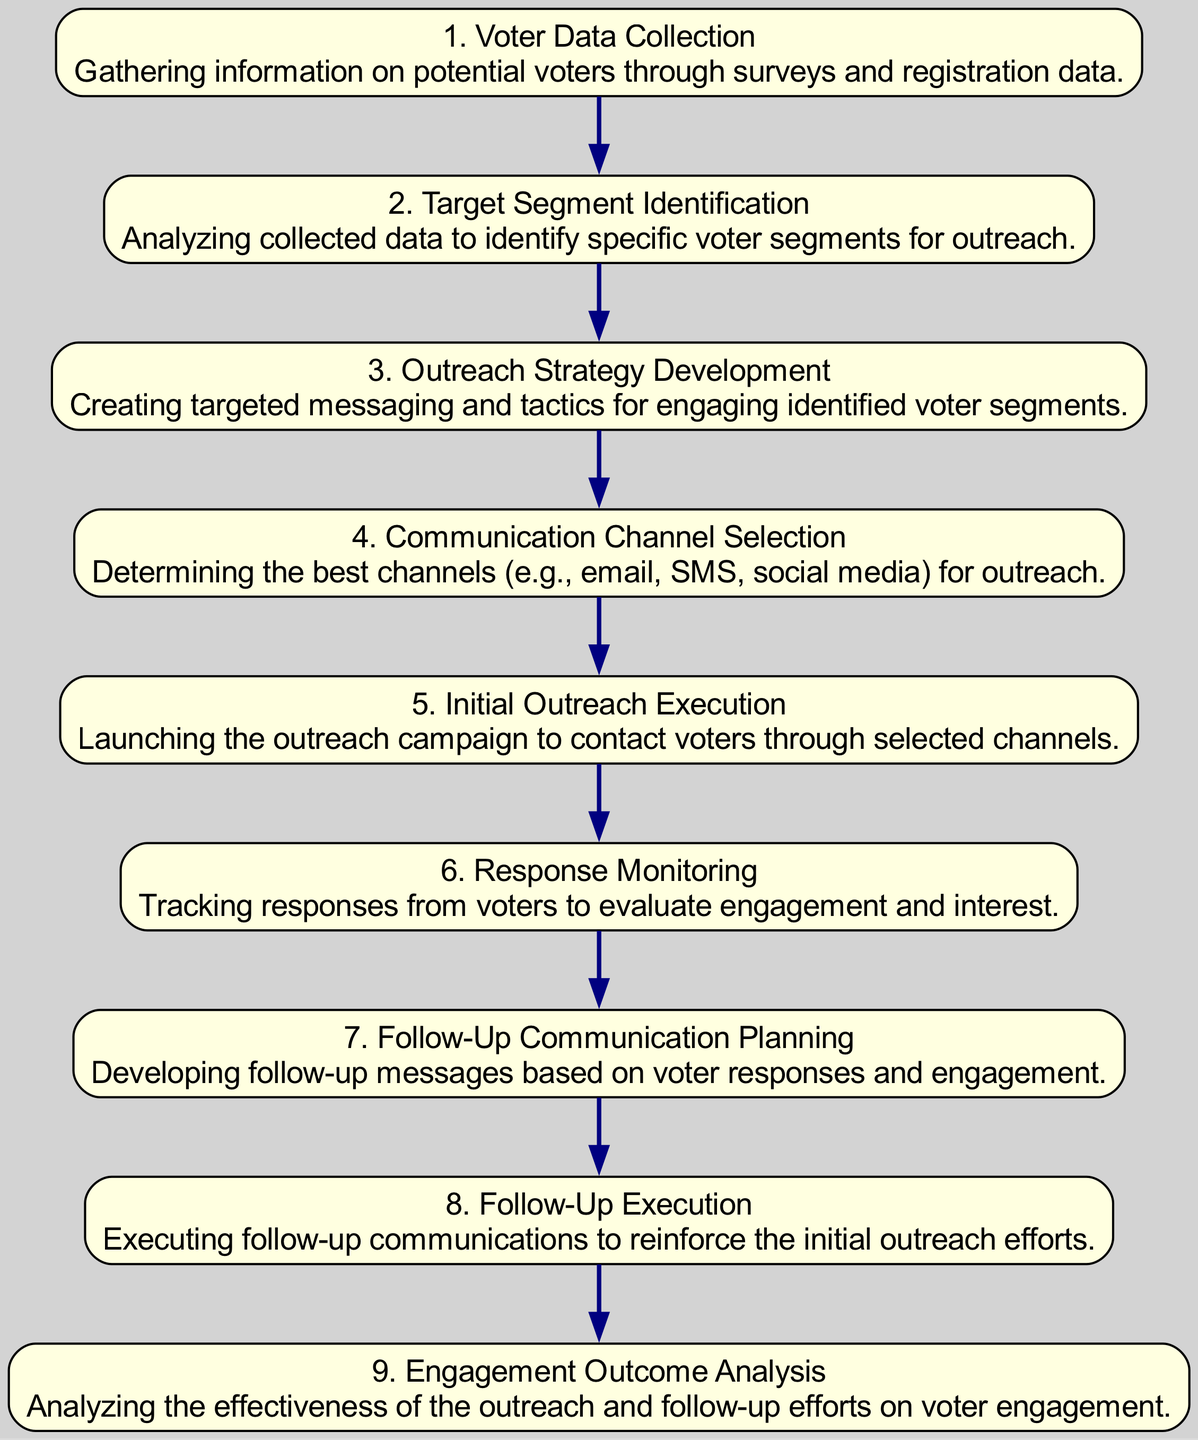What is the first step in the sequence? The first step listed in the diagram is "Voter Data Collection," which is noted as gathering information on potential voters.
Answer: Voter Data Collection How many total steps are there in the outreach sequence? Counting each part of the sequence from the diagram, there are nine distinct steps outlined.
Answer: 9 What is the last step in the sequence? The last step detailed in the diagram is "Engagement Outcome Analysis," which involves analyzing the effectiveness of outreach efforts.
Answer: Engagement Outcome Analysis What follows the "Initial Outreach Execution"? Immediately after "Initial Outreach Execution" in the sequence is "Response Monitoring," which tracks voter responses to the outreach.
Answer: Response Monitoring Which step involves analyzing collected data? The step specifically focused on analyzing the collected data to identify voter segments is titled "Target Segment Identification."
Answer: Target Segment Identification What is the purpose of the "Follow-Up Communication Planning" step? This step is dedicated to developing follow-up messages based on the responses and engagement from voters.
Answer: Developing follow-up messages In which step is the outreach campaign actually launched? The outreach campaign is launched in the step called "Initial Outreach Execution."
Answer: Initial Outreach Execution What comes before "Follow-Up Execution"? The step that occurs before "Follow-Up Execution" is "Follow-Up Communication Planning," which is crucial for strategizing the follow-up.
Answer: Follow-Up Communication Planning How are the outreach strategy and messaging tailored? The outreach strategy and messaging are tailored during the "Outreach Strategy Development" step, which focuses on creating targeted tactics.
Answer: Outreach Strategy Development 